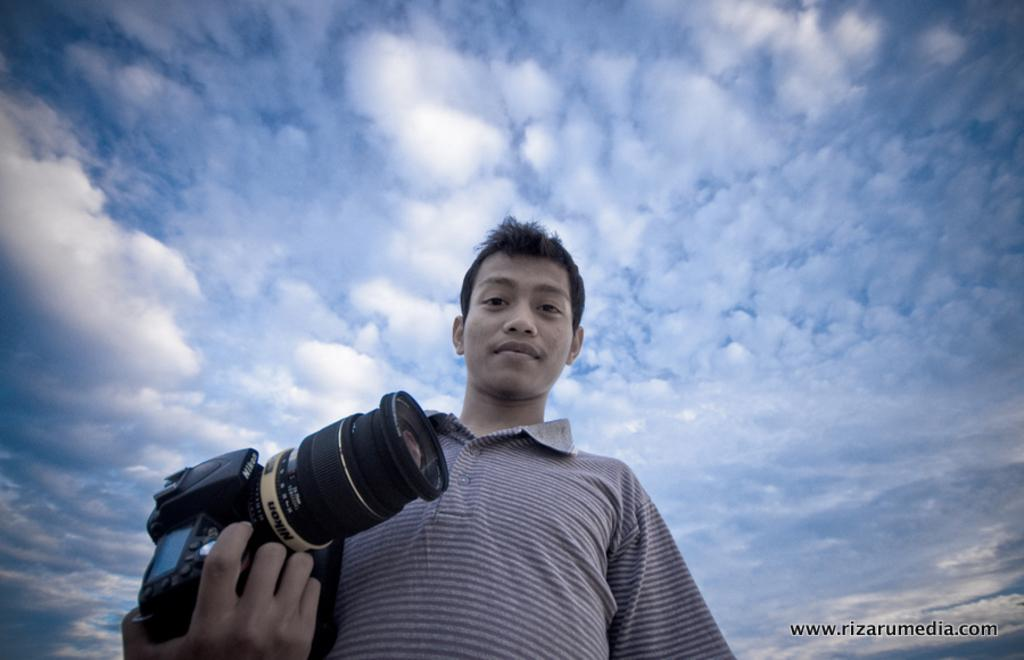Who is the main subject in the image? There is a man in the image. What is the man holding in the image? The man is holding a camera. What can be seen in the background of the image? The sky is visible in the image. How would you describe the sky in the image? The sky appears to be cloudy. How many babies are visible in the image? There are no babies present in the image. Is there a veil visible in the image? There is no veil present in the image. 